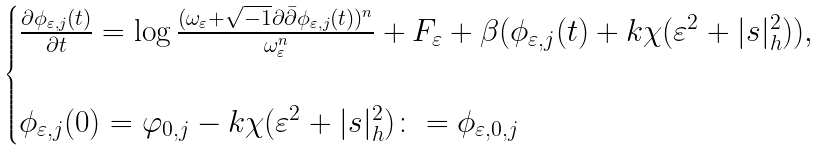Convert formula to latex. <formula><loc_0><loc_0><loc_500><loc_500>\begin{cases} \frac { \partial \phi _ { \varepsilon , j } ( t ) } { \partial t } = \log \frac { ( \omega _ { \varepsilon } + \sqrt { - 1 } \partial \bar { \partial } \phi _ { \varepsilon , j } ( t ) ) ^ { n } } { \omega _ { \varepsilon } ^ { n } } + F _ { \varepsilon } + \beta ( \phi _ { \varepsilon , j } ( t ) + k \chi ( \varepsilon ^ { 2 } + | s | _ { h } ^ { 2 } ) ) , \\ \\ \phi _ { \varepsilon , j } ( 0 ) = \varphi _ { 0 , j } - k \chi ( \varepsilon ^ { 2 } + | s | _ { h } ^ { 2 } ) \colon = \phi _ { \varepsilon , 0 , j } \\ \end{cases}</formula> 